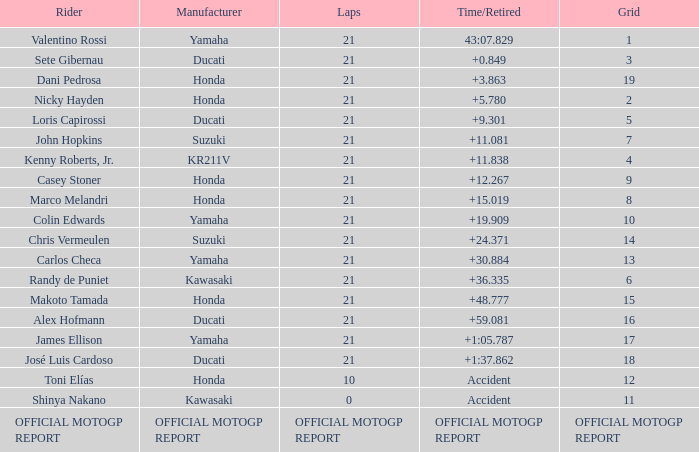What was the amount of laps for the vehicle manufactured by honda with a grid of 9? 21.0. 